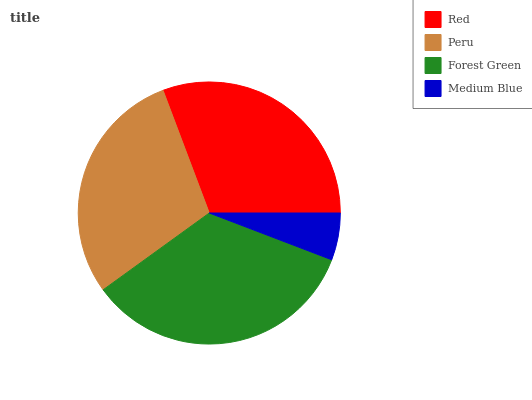Is Medium Blue the minimum?
Answer yes or no. Yes. Is Forest Green the maximum?
Answer yes or no. Yes. Is Peru the minimum?
Answer yes or no. No. Is Peru the maximum?
Answer yes or no. No. Is Red greater than Peru?
Answer yes or no. Yes. Is Peru less than Red?
Answer yes or no. Yes. Is Peru greater than Red?
Answer yes or no. No. Is Red less than Peru?
Answer yes or no. No. Is Red the high median?
Answer yes or no. Yes. Is Peru the low median?
Answer yes or no. Yes. Is Peru the high median?
Answer yes or no. No. Is Medium Blue the low median?
Answer yes or no. No. 